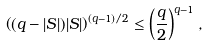<formula> <loc_0><loc_0><loc_500><loc_500>\left ( ( q - | S | ) | S | \right ) ^ { ( q - 1 ) / 2 } \leq \left ( \frac { q } { 2 } \right ) ^ { q - 1 } ,</formula> 